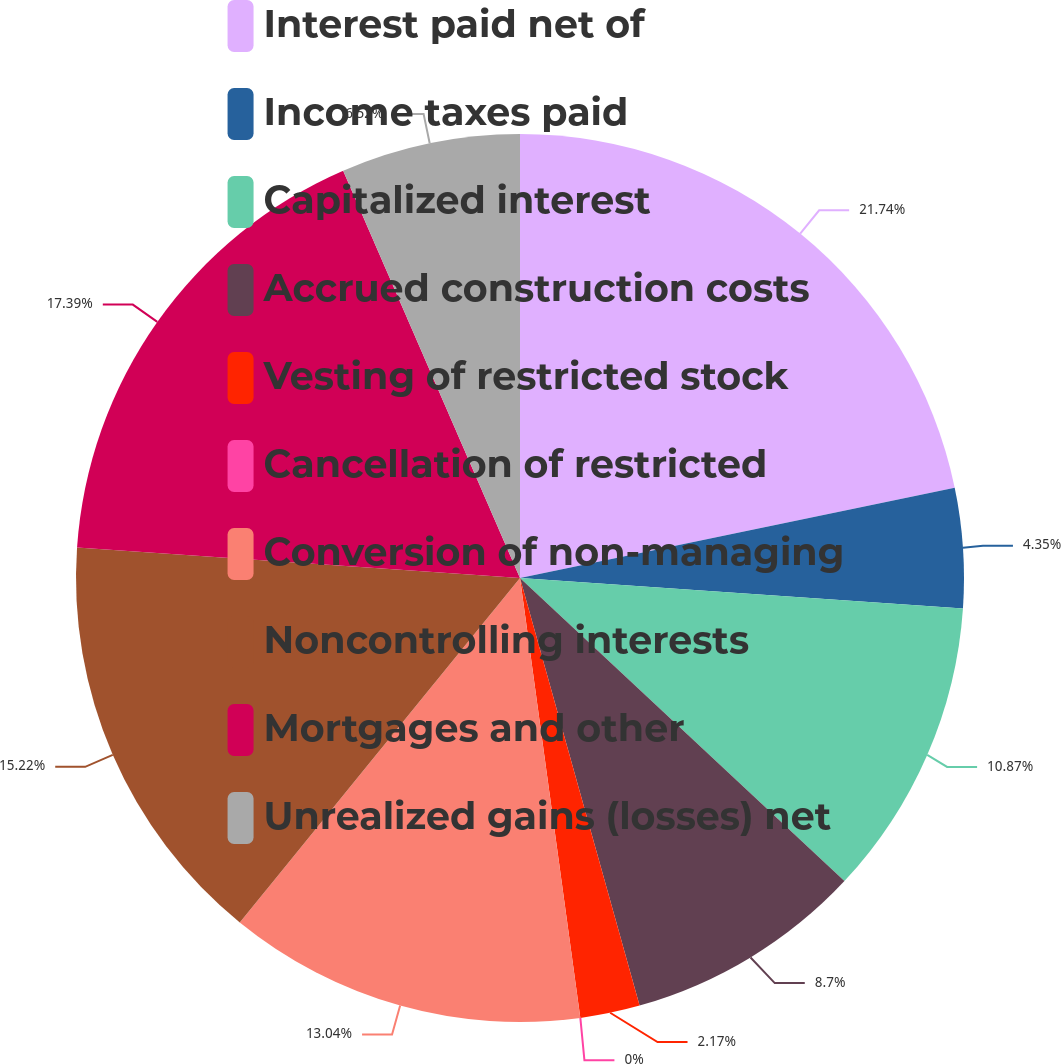Convert chart. <chart><loc_0><loc_0><loc_500><loc_500><pie_chart><fcel>Interest paid net of<fcel>Income taxes paid<fcel>Capitalized interest<fcel>Accrued construction costs<fcel>Vesting of restricted stock<fcel>Cancellation of restricted<fcel>Conversion of non-managing<fcel>Noncontrolling interests<fcel>Mortgages and other<fcel>Unrealized gains (losses) net<nl><fcel>21.74%<fcel>4.35%<fcel>10.87%<fcel>8.7%<fcel>2.17%<fcel>0.0%<fcel>13.04%<fcel>15.22%<fcel>17.39%<fcel>6.52%<nl></chart> 